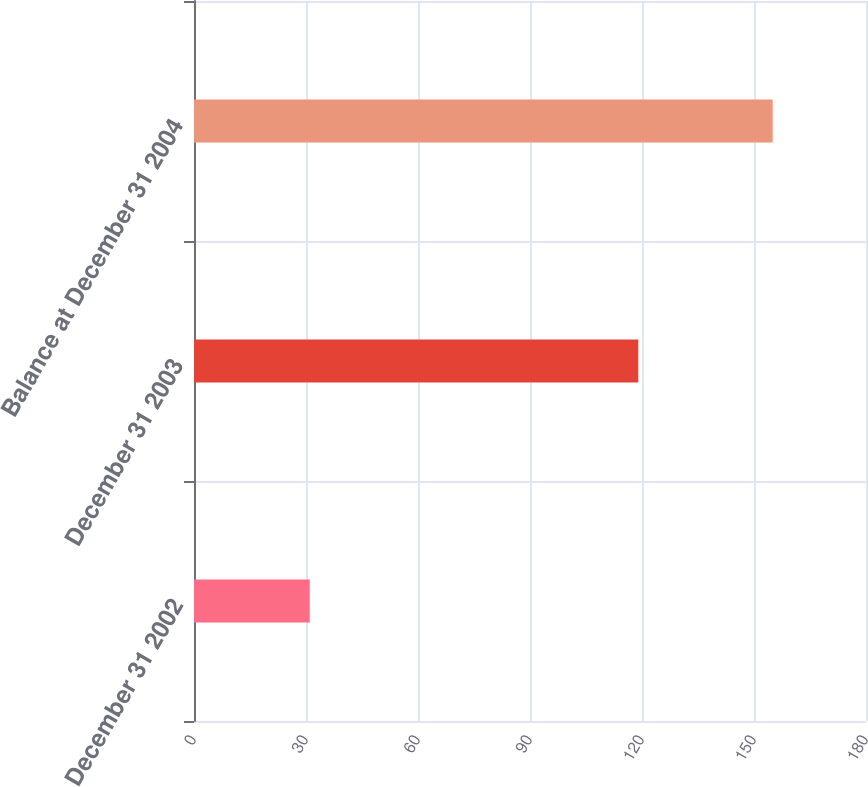<chart> <loc_0><loc_0><loc_500><loc_500><bar_chart><fcel>December 31 2002<fcel>December 31 2003<fcel>Balance at December 31 2004<nl><fcel>31<fcel>119<fcel>155<nl></chart> 